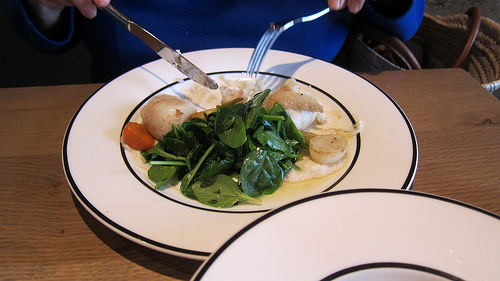<image>
Is there a fork to the right of the knife? Yes. From this viewpoint, the fork is positioned to the right side relative to the knife. 